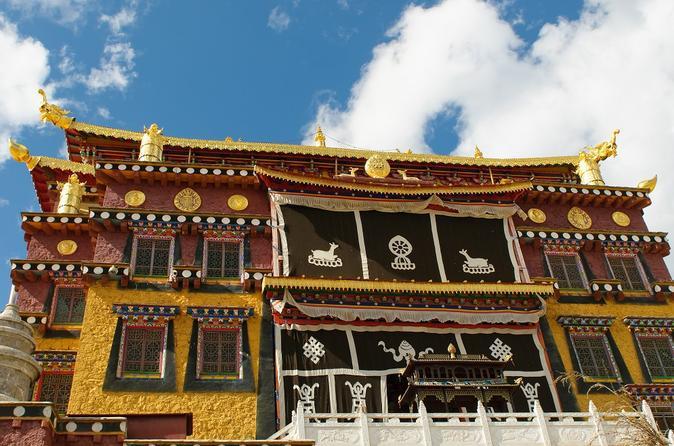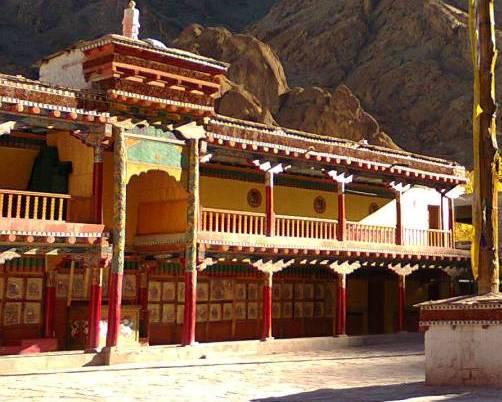The first image is the image on the left, the second image is the image on the right. Assess this claim about the two images: "Both buildings have flat roofs with no curves on the sides.". Correct or not? Answer yes or no. No. 